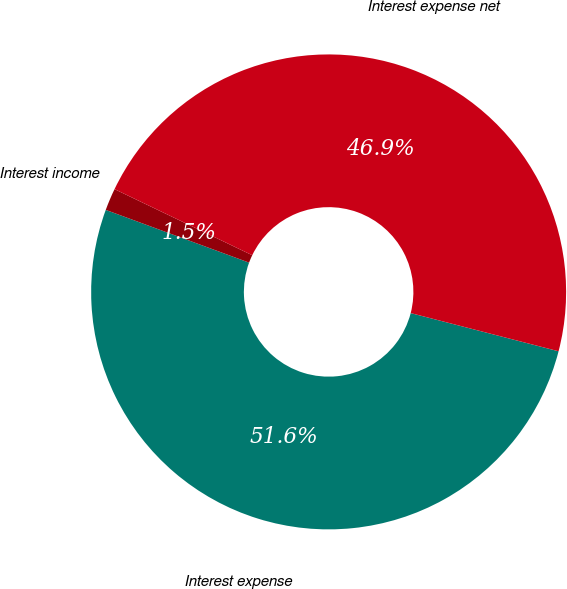<chart> <loc_0><loc_0><loc_500><loc_500><pie_chart><fcel>Interest expense<fcel>Interest income<fcel>Interest expense net<nl><fcel>51.59%<fcel>1.51%<fcel>46.9%<nl></chart> 